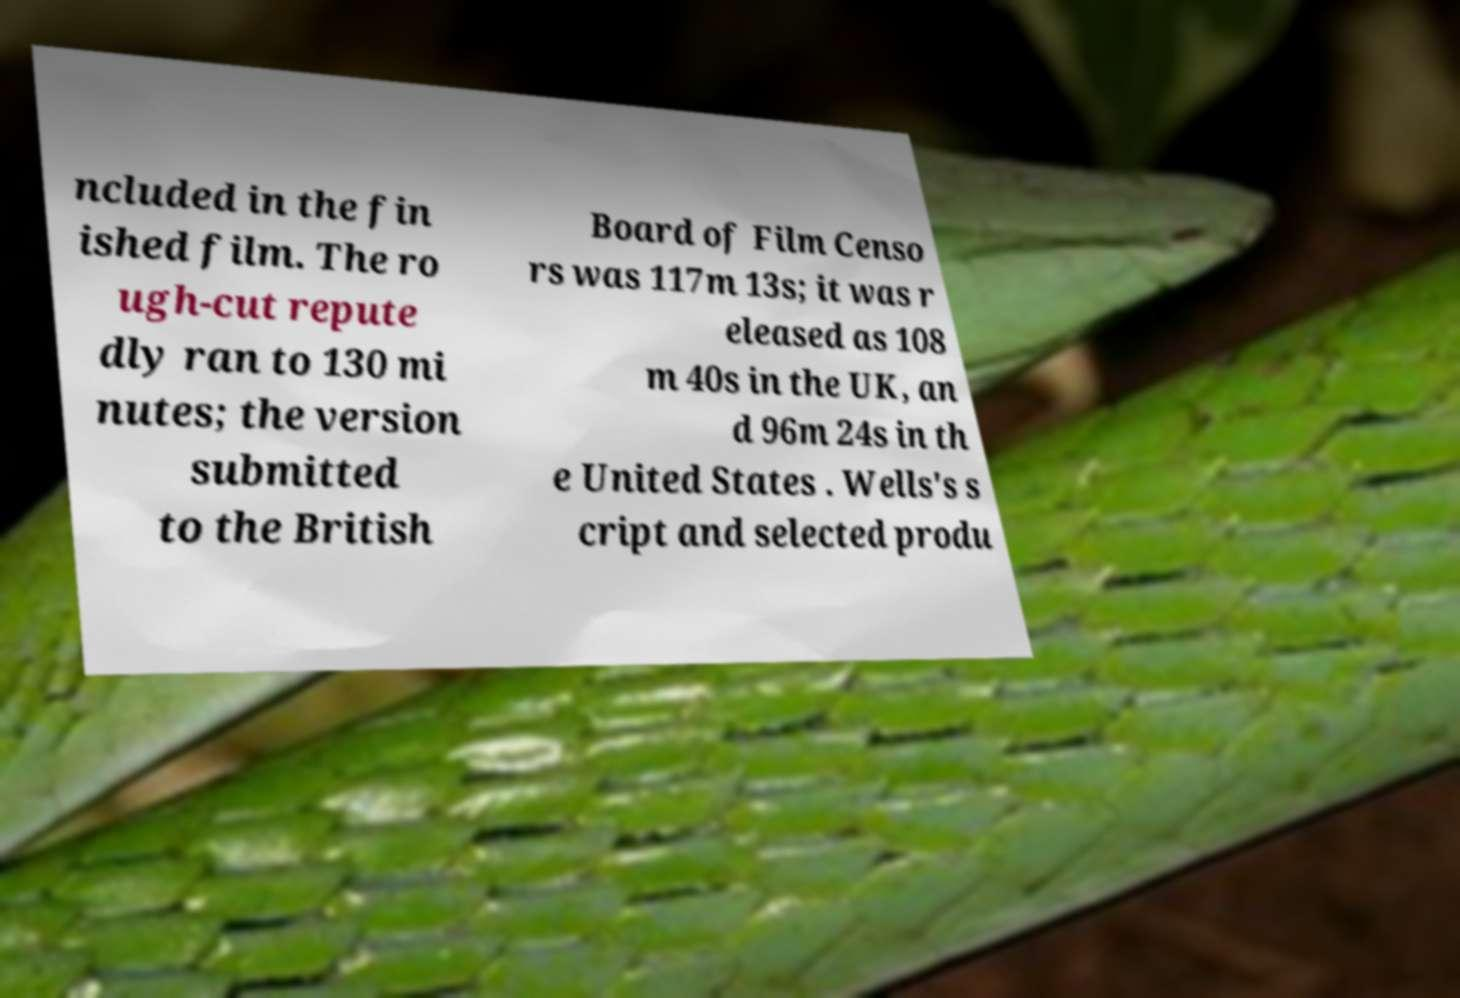Can you read and provide the text displayed in the image?This photo seems to have some interesting text. Can you extract and type it out for me? ncluded in the fin ished film. The ro ugh-cut repute dly ran to 130 mi nutes; the version submitted to the British Board of Film Censo rs was 117m 13s; it was r eleased as 108 m 40s in the UK, an d 96m 24s in th e United States . Wells's s cript and selected produ 